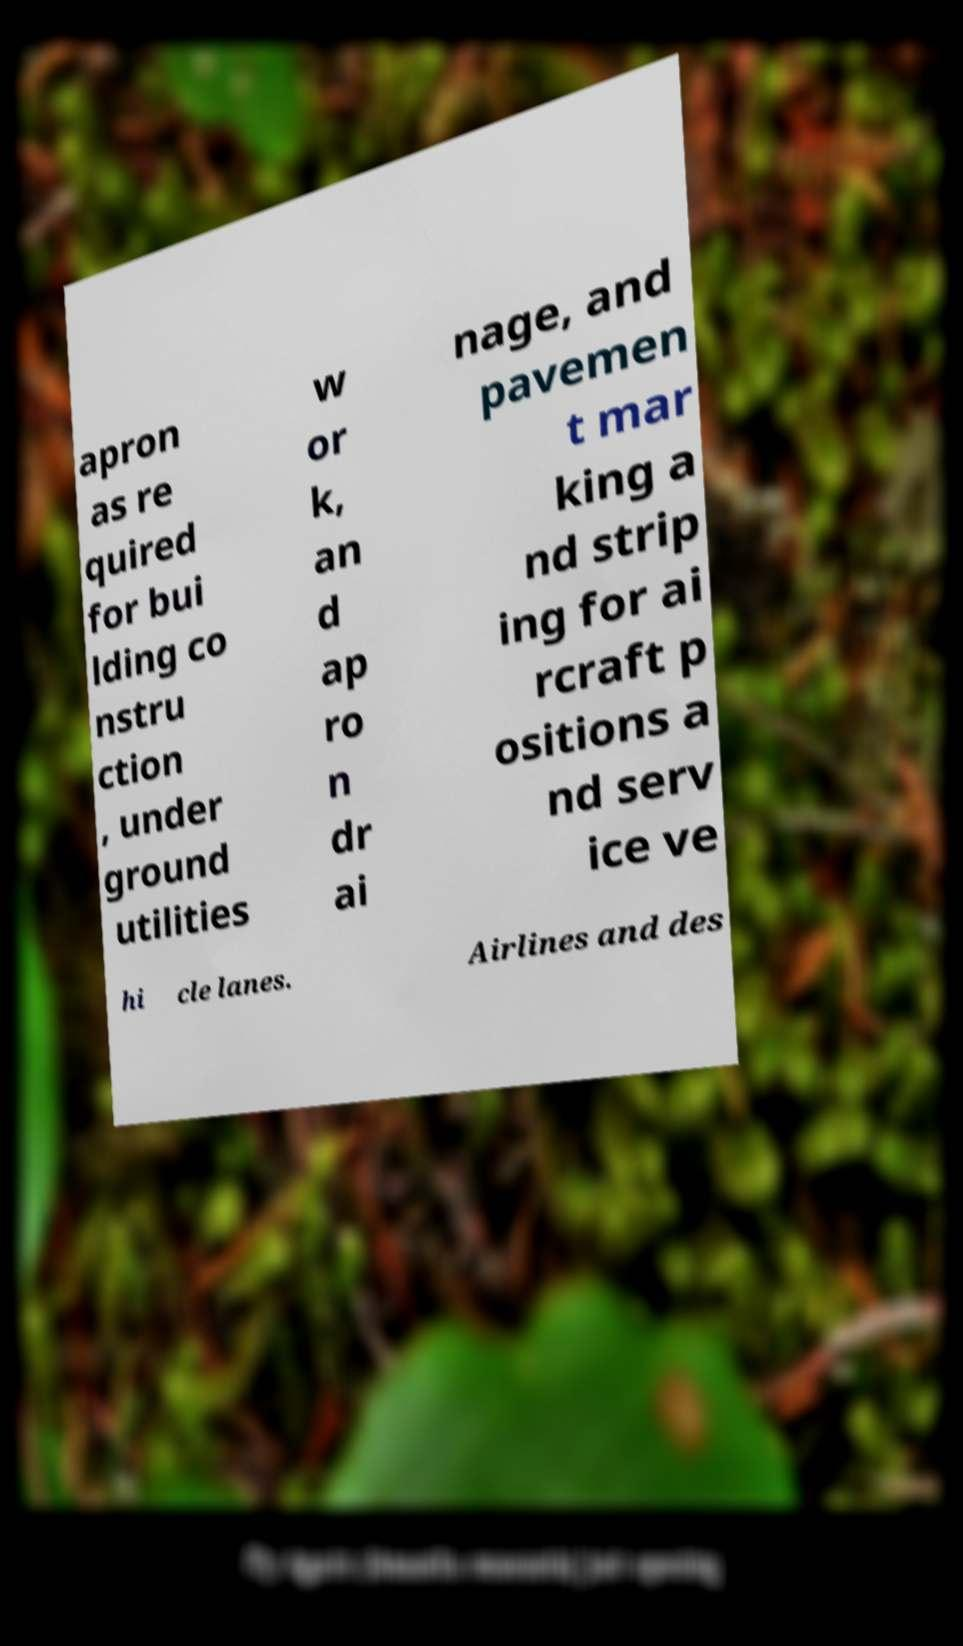Could you extract and type out the text from this image? apron as re quired for bui lding co nstru ction , under ground utilities w or k, an d ap ro n dr ai nage, and pavemen t mar king a nd strip ing for ai rcraft p ositions a nd serv ice ve hi cle lanes. Airlines and des 